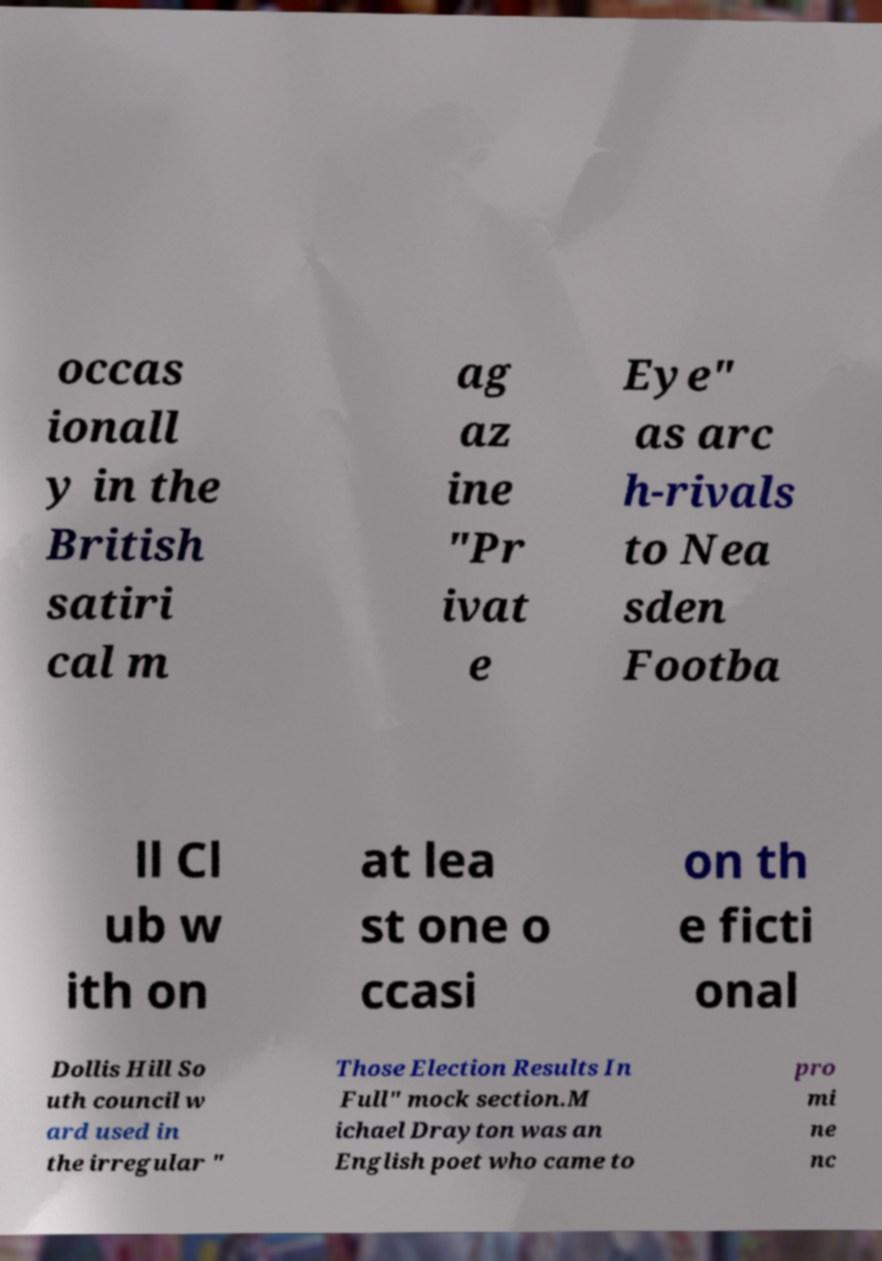I need the written content from this picture converted into text. Can you do that? occas ionall y in the British satiri cal m ag az ine "Pr ivat e Eye" as arc h-rivals to Nea sden Footba ll Cl ub w ith on at lea st one o ccasi on th e ficti onal Dollis Hill So uth council w ard used in the irregular " Those Election Results In Full" mock section.M ichael Drayton was an English poet who came to pro mi ne nc 